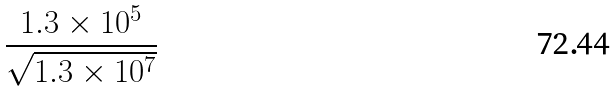<formula> <loc_0><loc_0><loc_500><loc_500>\frac { 1 . 3 \times 1 0 ^ { 5 } } { \sqrt { 1 . 3 \times 1 0 ^ { 7 } } }</formula> 